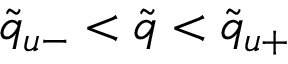Convert formula to latex. <formula><loc_0><loc_0><loc_500><loc_500>\tilde { q } _ { u - } < \tilde { q } < \tilde { q } _ { u + }</formula> 